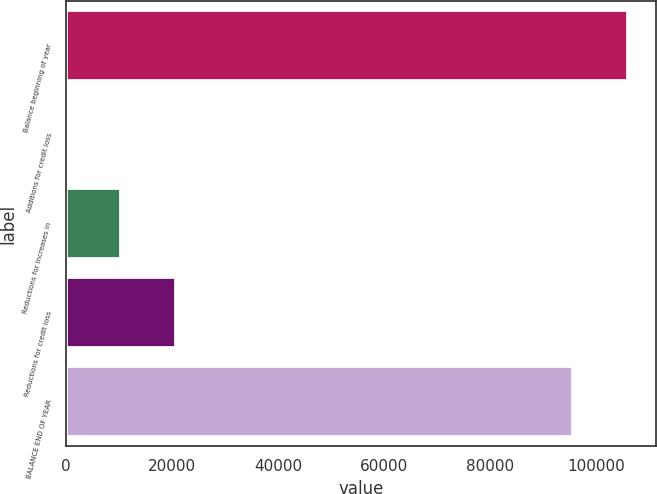<chart> <loc_0><loc_0><loc_500><loc_500><bar_chart><fcel>Balance beginning of year<fcel>Additions for credit loss<fcel>Reductions for increases in<fcel>Reductions for credit loss<fcel>BALANCE END OF YEAR<nl><fcel>105892<fcel>56<fcel>10359.4<fcel>20662.8<fcel>95589<nl></chart> 